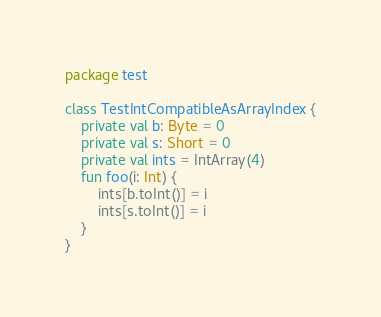Convert code to text. <code><loc_0><loc_0><loc_500><loc_500><_Kotlin_>package test

class TestIntCompatibleAsArrayIndex {
    private val b: Byte = 0
    private val s: Short = 0
    private val ints = IntArray(4)
    fun foo(i: Int) {
        ints[b.toInt()] = i
        ints[s.toInt()] = i
    }
}</code> 